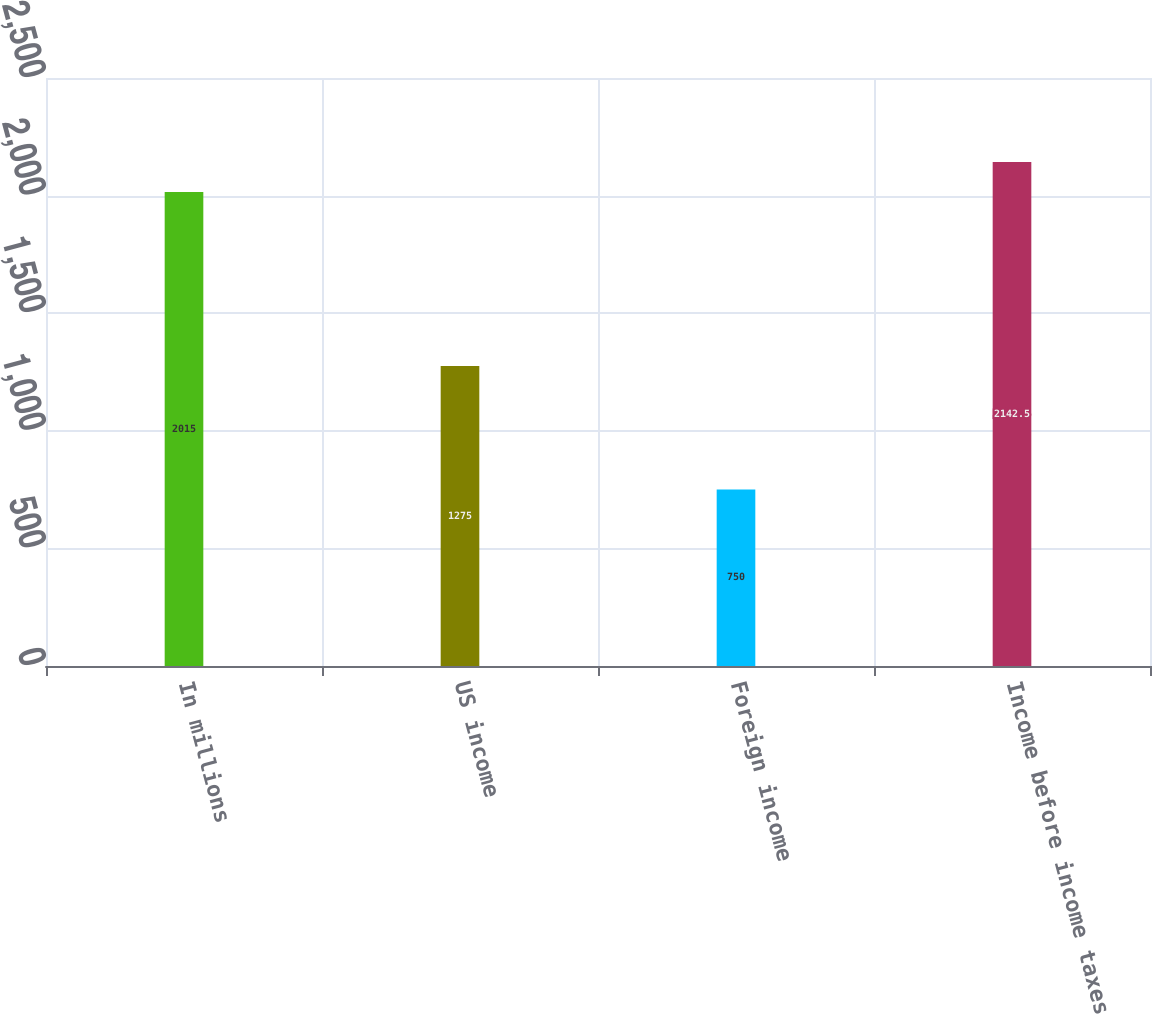Convert chart to OTSL. <chart><loc_0><loc_0><loc_500><loc_500><bar_chart><fcel>In millions<fcel>US income<fcel>Foreign income<fcel>Income before income taxes<nl><fcel>2015<fcel>1275<fcel>750<fcel>2142.5<nl></chart> 